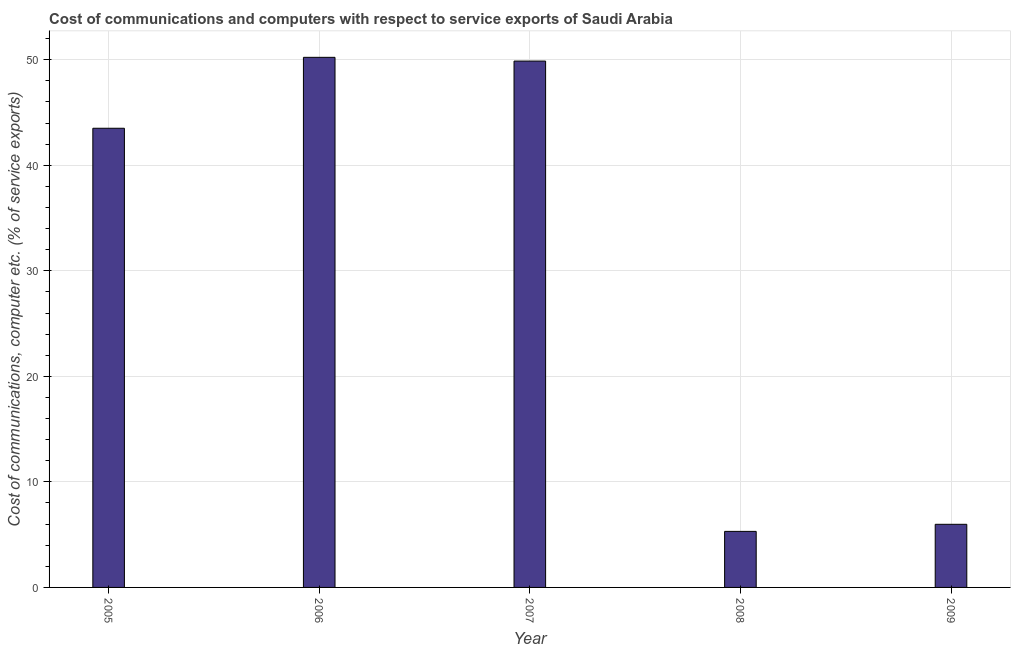Does the graph contain any zero values?
Ensure brevity in your answer.  No. Does the graph contain grids?
Provide a short and direct response. Yes. What is the title of the graph?
Give a very brief answer. Cost of communications and computers with respect to service exports of Saudi Arabia. What is the label or title of the X-axis?
Ensure brevity in your answer.  Year. What is the label or title of the Y-axis?
Give a very brief answer. Cost of communications, computer etc. (% of service exports). What is the cost of communications and computer in 2007?
Provide a short and direct response. 49.87. Across all years, what is the maximum cost of communications and computer?
Offer a terse response. 50.22. Across all years, what is the minimum cost of communications and computer?
Give a very brief answer. 5.31. In which year was the cost of communications and computer maximum?
Provide a short and direct response. 2006. What is the sum of the cost of communications and computer?
Your answer should be very brief. 154.89. What is the difference between the cost of communications and computer in 2005 and 2008?
Make the answer very short. 38.2. What is the average cost of communications and computer per year?
Offer a terse response. 30.98. What is the median cost of communications and computer?
Ensure brevity in your answer.  43.5. In how many years, is the cost of communications and computer greater than 10 %?
Give a very brief answer. 3. What is the ratio of the cost of communications and computer in 2008 to that in 2009?
Offer a very short reply. 0.89. Is the cost of communications and computer in 2005 less than that in 2006?
Your answer should be compact. Yes. Is the difference between the cost of communications and computer in 2008 and 2009 greater than the difference between any two years?
Give a very brief answer. No. What is the difference between the highest and the second highest cost of communications and computer?
Provide a succinct answer. 0.35. Is the sum of the cost of communications and computer in 2005 and 2006 greater than the maximum cost of communications and computer across all years?
Provide a succinct answer. Yes. What is the difference between the highest and the lowest cost of communications and computer?
Make the answer very short. 44.92. Are all the bars in the graph horizontal?
Offer a very short reply. No. How many years are there in the graph?
Your answer should be compact. 5. What is the difference between two consecutive major ticks on the Y-axis?
Your answer should be very brief. 10. Are the values on the major ticks of Y-axis written in scientific E-notation?
Keep it short and to the point. No. What is the Cost of communications, computer etc. (% of service exports) of 2005?
Your answer should be compact. 43.5. What is the Cost of communications, computer etc. (% of service exports) in 2006?
Ensure brevity in your answer.  50.22. What is the Cost of communications, computer etc. (% of service exports) in 2007?
Offer a very short reply. 49.87. What is the Cost of communications, computer etc. (% of service exports) in 2008?
Provide a succinct answer. 5.31. What is the Cost of communications, computer etc. (% of service exports) in 2009?
Your answer should be compact. 5.98. What is the difference between the Cost of communications, computer etc. (% of service exports) in 2005 and 2006?
Ensure brevity in your answer.  -6.72. What is the difference between the Cost of communications, computer etc. (% of service exports) in 2005 and 2007?
Your response must be concise. -6.37. What is the difference between the Cost of communications, computer etc. (% of service exports) in 2005 and 2008?
Keep it short and to the point. 38.2. What is the difference between the Cost of communications, computer etc. (% of service exports) in 2005 and 2009?
Your response must be concise. 37.52. What is the difference between the Cost of communications, computer etc. (% of service exports) in 2006 and 2007?
Keep it short and to the point. 0.36. What is the difference between the Cost of communications, computer etc. (% of service exports) in 2006 and 2008?
Offer a terse response. 44.92. What is the difference between the Cost of communications, computer etc. (% of service exports) in 2006 and 2009?
Your answer should be very brief. 44.24. What is the difference between the Cost of communications, computer etc. (% of service exports) in 2007 and 2008?
Provide a succinct answer. 44.56. What is the difference between the Cost of communications, computer etc. (% of service exports) in 2007 and 2009?
Ensure brevity in your answer.  43.89. What is the difference between the Cost of communications, computer etc. (% of service exports) in 2008 and 2009?
Ensure brevity in your answer.  -0.67. What is the ratio of the Cost of communications, computer etc. (% of service exports) in 2005 to that in 2006?
Offer a terse response. 0.87. What is the ratio of the Cost of communications, computer etc. (% of service exports) in 2005 to that in 2007?
Provide a succinct answer. 0.87. What is the ratio of the Cost of communications, computer etc. (% of service exports) in 2005 to that in 2008?
Your response must be concise. 8.19. What is the ratio of the Cost of communications, computer etc. (% of service exports) in 2005 to that in 2009?
Offer a terse response. 7.27. What is the ratio of the Cost of communications, computer etc. (% of service exports) in 2006 to that in 2007?
Offer a terse response. 1.01. What is the ratio of the Cost of communications, computer etc. (% of service exports) in 2006 to that in 2008?
Offer a very short reply. 9.46. What is the ratio of the Cost of communications, computer etc. (% of service exports) in 2006 to that in 2009?
Provide a short and direct response. 8.4. What is the ratio of the Cost of communications, computer etc. (% of service exports) in 2007 to that in 2008?
Offer a terse response. 9.39. What is the ratio of the Cost of communications, computer etc. (% of service exports) in 2007 to that in 2009?
Your response must be concise. 8.34. What is the ratio of the Cost of communications, computer etc. (% of service exports) in 2008 to that in 2009?
Your response must be concise. 0.89. 